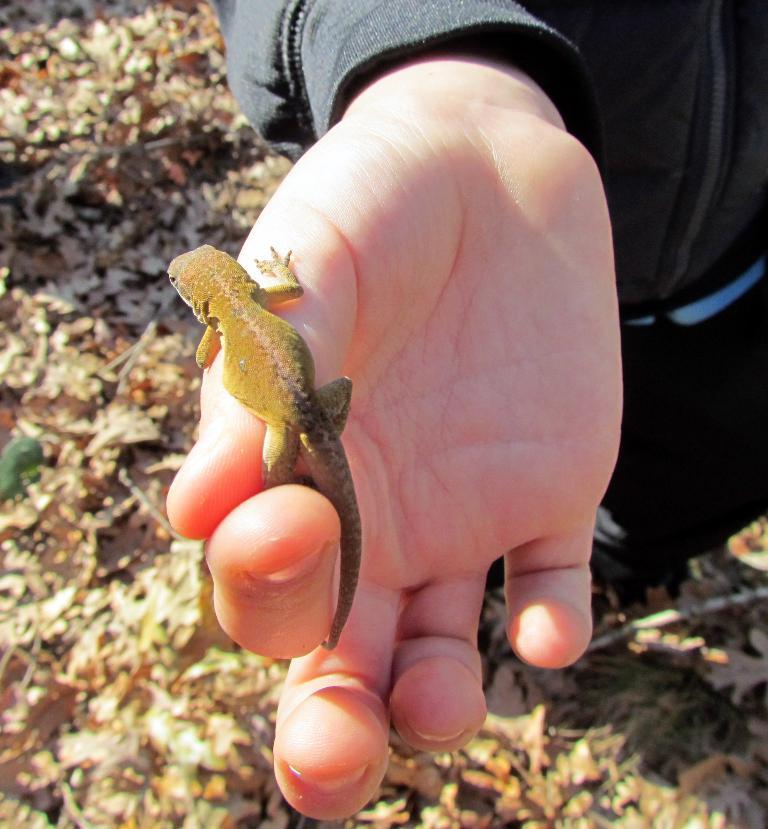Can you describe this image briefly? This image consists of a person's hand. On that there is a lizard. 